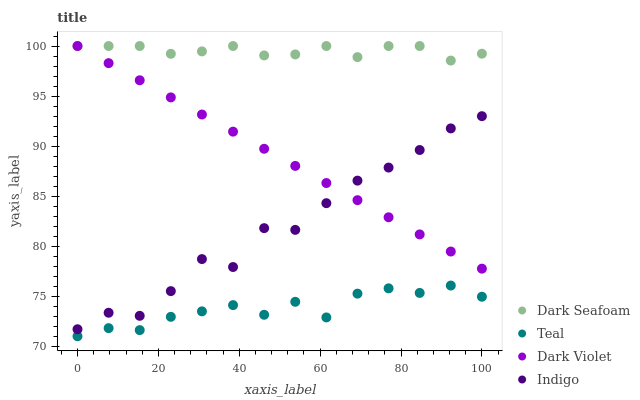Does Teal have the minimum area under the curve?
Answer yes or no. Yes. Does Dark Seafoam have the maximum area under the curve?
Answer yes or no. Yes. Does Indigo have the minimum area under the curve?
Answer yes or no. No. Does Indigo have the maximum area under the curve?
Answer yes or no. No. Is Dark Violet the smoothest?
Answer yes or no. Yes. Is Indigo the roughest?
Answer yes or no. Yes. Is Indigo the smoothest?
Answer yes or no. No. Is Dark Violet the roughest?
Answer yes or no. No. Does Teal have the lowest value?
Answer yes or no. Yes. Does Indigo have the lowest value?
Answer yes or no. No. Does Dark Violet have the highest value?
Answer yes or no. Yes. Does Indigo have the highest value?
Answer yes or no. No. Is Teal less than Dark Seafoam?
Answer yes or no. Yes. Is Dark Seafoam greater than Indigo?
Answer yes or no. Yes. Does Indigo intersect Dark Violet?
Answer yes or no. Yes. Is Indigo less than Dark Violet?
Answer yes or no. No. Is Indigo greater than Dark Violet?
Answer yes or no. No. Does Teal intersect Dark Seafoam?
Answer yes or no. No. 